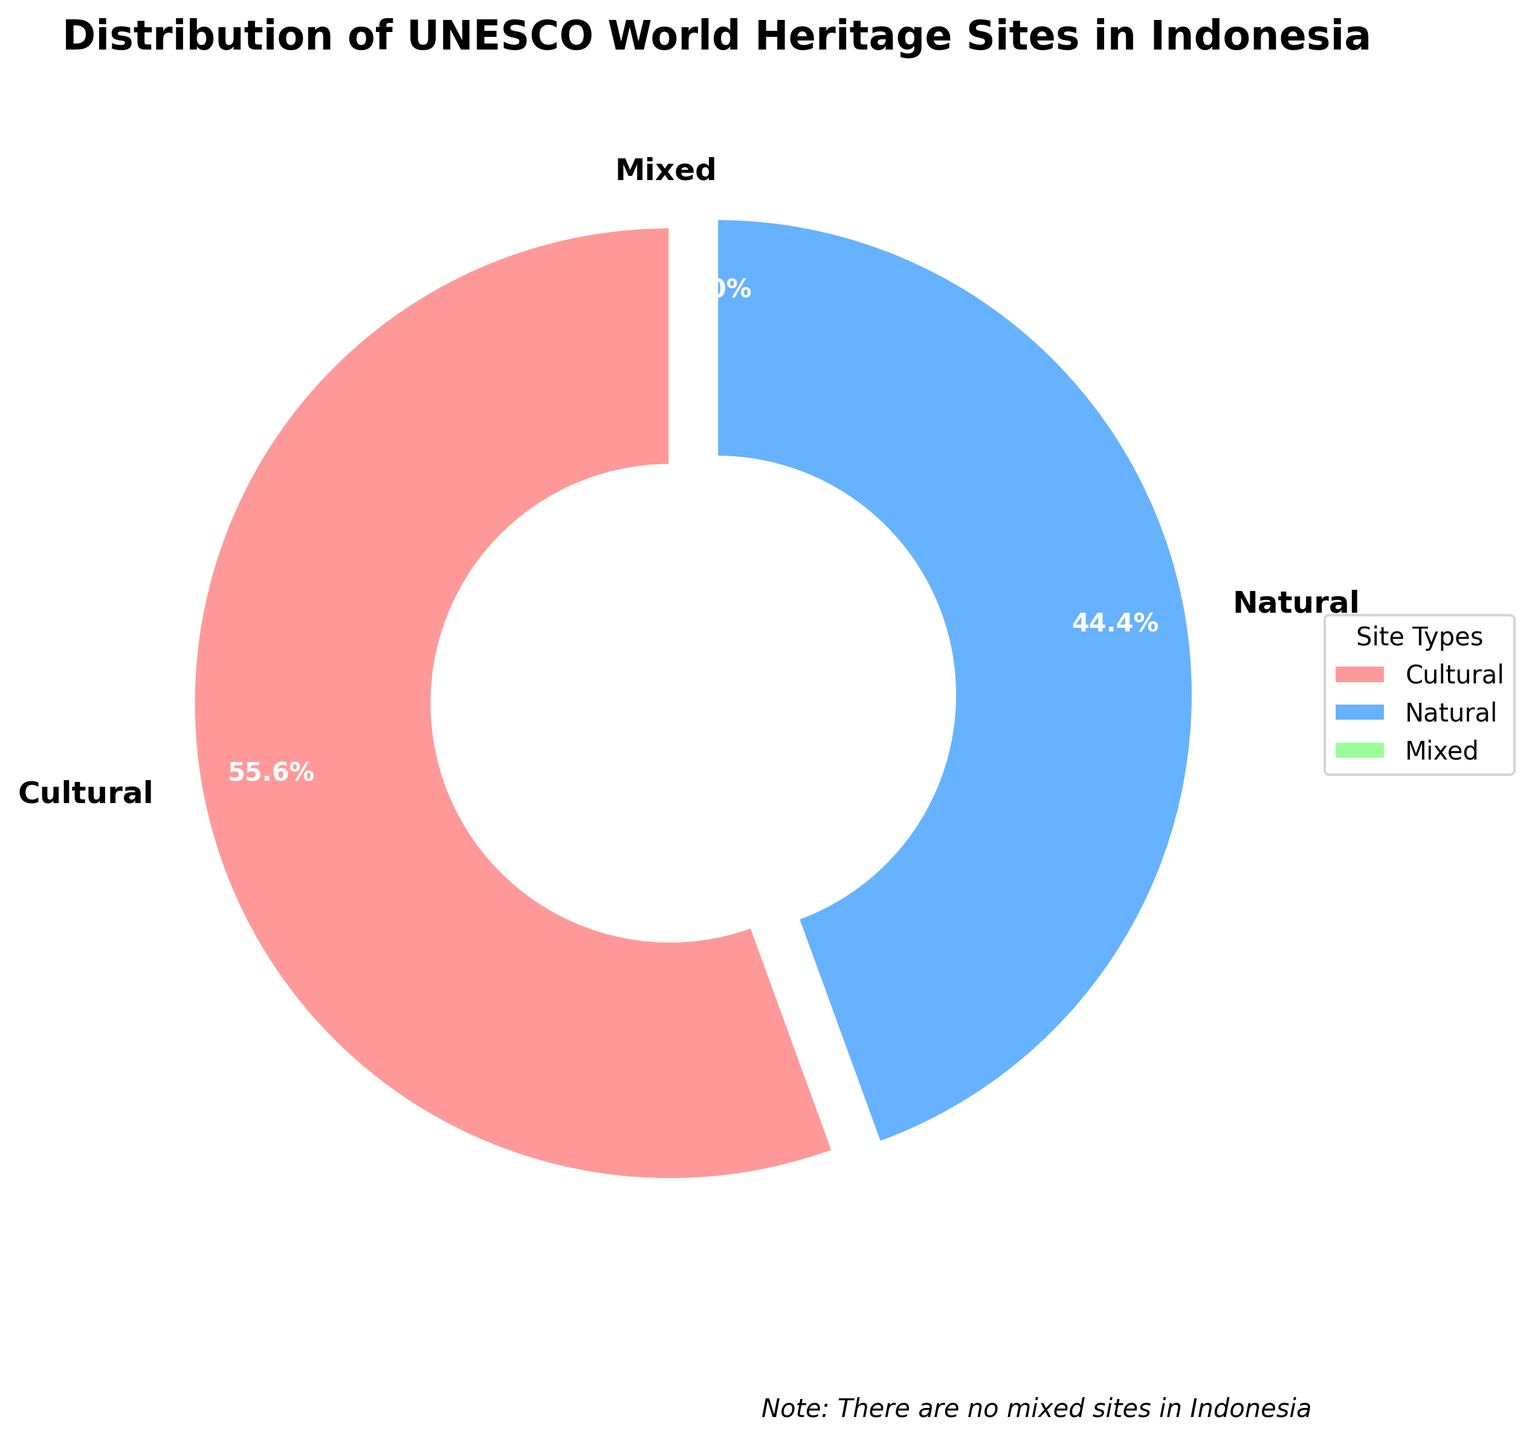What percentage of UNESCO World Heritage Sites in Indonesia are cultural? The pie chart shows that cultural sites make up 5 out of the total 9 sites. To calculate the percentage, divide the number of cultural sites by the total number of sites and multiply by 100: (5/9) * 100 ≈ 55.6%.
Answer: 55.6% How many more cultural sites than natural sites are there in Indonesia? The pie chart shows there are 5 cultural sites and 4 natural sites. The difference is 5 - 4 = 1.
Answer: 1 What is the proportion of natural sites to the total number of sites? There are 4 natural sites out of a total of 9 sites. The proportion is 4/9 ≈ 0.44.
Answer: 0.44 Which type of UNESCO World Heritage Site has the highest percentage in Indonesia? The pie chart shows the percentages of each type. The cultural sites have the highest percentage at 55.6%.
Answer: Cultural Are there any mixed sites in Indonesia according to the figure? The pie chart indicates the number of sites for each type. It shows 0 mixed sites.
Answer: No What percentage of the total sites are either natural or mixed? Add the number of natural and mixed sites, then divide by the total number of sites and multiply by 100: (4+0)/9 * 100 ≈ 44.4%.
Answer: 44.4% By how much do cultural sites exceed half of the total? Half of the total number of sites is 9/2 = 4.5. Cultural sites are 5, so they exceed half of the total by 5 - 4.5 = 0.5.
Answer: 0.5 What are the colors used for the different types of sites in the pie chart? The visual attributes show that the colors used are red for cultural, blue for natural, and green for mixed sites.
Answer: Red, blue, green What is the start angle of the pie chart, and why is it important? The pie chart starts at a 90-degree angle, which is conventionally used to ensure one segment starts from the top, helping viewers read the chart more easily.
Answer: 90 degrees 